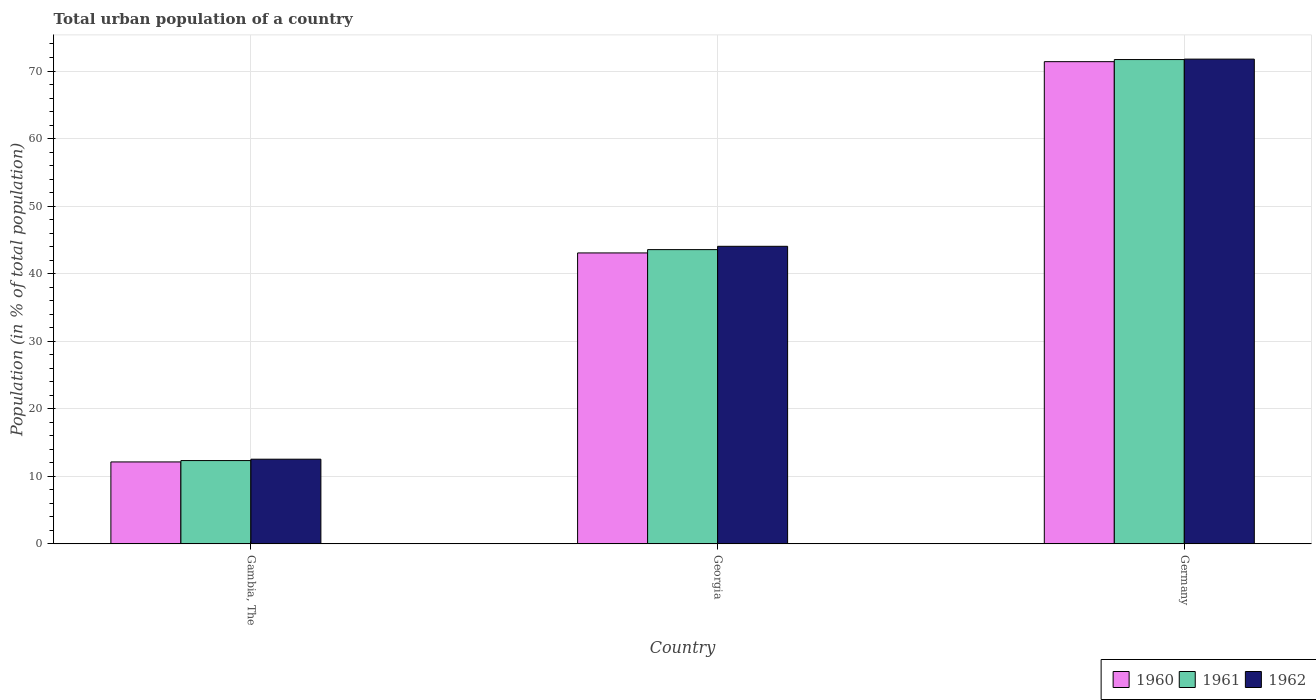How many different coloured bars are there?
Keep it short and to the point. 3. Are the number of bars per tick equal to the number of legend labels?
Your answer should be compact. Yes. Are the number of bars on each tick of the X-axis equal?
Provide a short and direct response. Yes. How many bars are there on the 1st tick from the right?
Provide a short and direct response. 3. What is the label of the 1st group of bars from the left?
Your answer should be very brief. Gambia, The. What is the urban population in 1962 in Georgia?
Provide a succinct answer. 44.05. Across all countries, what is the maximum urban population in 1961?
Your answer should be very brief. 71.7. Across all countries, what is the minimum urban population in 1962?
Your response must be concise. 12.54. In which country was the urban population in 1962 minimum?
Keep it short and to the point. Gambia, The. What is the total urban population in 1960 in the graph?
Provide a short and direct response. 126.58. What is the difference between the urban population in 1961 in Georgia and that in Germany?
Ensure brevity in your answer.  -28.14. What is the difference between the urban population in 1960 in Gambia, The and the urban population in 1962 in Georgia?
Give a very brief answer. -31.92. What is the average urban population in 1960 per country?
Your response must be concise. 42.19. What is the difference between the urban population of/in 1961 and urban population of/in 1962 in Georgia?
Keep it short and to the point. -0.49. What is the ratio of the urban population in 1961 in Georgia to that in Germany?
Make the answer very short. 0.61. Is the urban population in 1961 in Gambia, The less than that in Germany?
Offer a very short reply. Yes. Is the difference between the urban population in 1961 in Georgia and Germany greater than the difference between the urban population in 1962 in Georgia and Germany?
Offer a terse response. No. What is the difference between the highest and the second highest urban population in 1961?
Your answer should be compact. 31.23. What is the difference between the highest and the lowest urban population in 1961?
Keep it short and to the point. 59.37. In how many countries, is the urban population in 1960 greater than the average urban population in 1960 taken over all countries?
Ensure brevity in your answer.  2. Is it the case that in every country, the sum of the urban population in 1961 and urban population in 1960 is greater than the urban population in 1962?
Keep it short and to the point. Yes. How many bars are there?
Your response must be concise. 9. Are all the bars in the graph horizontal?
Ensure brevity in your answer.  No. How many countries are there in the graph?
Keep it short and to the point. 3. Are the values on the major ticks of Y-axis written in scientific E-notation?
Your response must be concise. No. What is the title of the graph?
Provide a short and direct response. Total urban population of a country. What is the label or title of the X-axis?
Offer a very short reply. Country. What is the label or title of the Y-axis?
Give a very brief answer. Population (in % of total population). What is the Population (in % of total population) in 1960 in Gambia, The?
Your answer should be compact. 12.13. What is the Population (in % of total population) in 1961 in Gambia, The?
Your answer should be compact. 12.33. What is the Population (in % of total population) of 1962 in Gambia, The?
Ensure brevity in your answer.  12.54. What is the Population (in % of total population) in 1960 in Georgia?
Offer a very short reply. 43.07. What is the Population (in % of total population) in 1961 in Georgia?
Your response must be concise. 43.56. What is the Population (in % of total population) of 1962 in Georgia?
Your answer should be compact. 44.05. What is the Population (in % of total population) in 1960 in Germany?
Make the answer very short. 71.38. What is the Population (in % of total population) in 1961 in Germany?
Your response must be concise. 71.7. What is the Population (in % of total population) in 1962 in Germany?
Your answer should be very brief. 71.76. Across all countries, what is the maximum Population (in % of total population) of 1960?
Provide a succinct answer. 71.38. Across all countries, what is the maximum Population (in % of total population) of 1961?
Provide a short and direct response. 71.7. Across all countries, what is the maximum Population (in % of total population) of 1962?
Give a very brief answer. 71.76. Across all countries, what is the minimum Population (in % of total population) of 1960?
Your response must be concise. 12.13. Across all countries, what is the minimum Population (in % of total population) of 1961?
Make the answer very short. 12.33. Across all countries, what is the minimum Population (in % of total population) in 1962?
Ensure brevity in your answer.  12.54. What is the total Population (in % of total population) of 1960 in the graph?
Ensure brevity in your answer.  126.58. What is the total Population (in % of total population) of 1961 in the graph?
Provide a succinct answer. 127.59. What is the total Population (in % of total population) in 1962 in the graph?
Your answer should be very brief. 128.35. What is the difference between the Population (in % of total population) in 1960 in Gambia, The and that in Georgia?
Your answer should be very brief. -30.94. What is the difference between the Population (in % of total population) of 1961 in Gambia, The and that in Georgia?
Provide a succinct answer. -31.23. What is the difference between the Population (in % of total population) of 1962 in Gambia, The and that in Georgia?
Offer a terse response. -31.52. What is the difference between the Population (in % of total population) in 1960 in Gambia, The and that in Germany?
Keep it short and to the point. -59.26. What is the difference between the Population (in % of total population) of 1961 in Gambia, The and that in Germany?
Offer a terse response. -59.37. What is the difference between the Population (in % of total population) in 1962 in Gambia, The and that in Germany?
Ensure brevity in your answer.  -59.23. What is the difference between the Population (in % of total population) of 1960 in Georgia and that in Germany?
Provide a short and direct response. -28.32. What is the difference between the Population (in % of total population) in 1961 in Georgia and that in Germany?
Offer a terse response. -28.14. What is the difference between the Population (in % of total population) in 1962 in Georgia and that in Germany?
Your answer should be very brief. -27.71. What is the difference between the Population (in % of total population) in 1960 in Gambia, The and the Population (in % of total population) in 1961 in Georgia?
Offer a terse response. -31.43. What is the difference between the Population (in % of total population) in 1960 in Gambia, The and the Population (in % of total population) in 1962 in Georgia?
Provide a short and direct response. -31.92. What is the difference between the Population (in % of total population) of 1961 in Gambia, The and the Population (in % of total population) of 1962 in Georgia?
Provide a short and direct response. -31.72. What is the difference between the Population (in % of total population) in 1960 in Gambia, The and the Population (in % of total population) in 1961 in Germany?
Your answer should be very brief. -59.57. What is the difference between the Population (in % of total population) of 1960 in Gambia, The and the Population (in % of total population) of 1962 in Germany?
Make the answer very short. -59.63. What is the difference between the Population (in % of total population) in 1961 in Gambia, The and the Population (in % of total population) in 1962 in Germany?
Keep it short and to the point. -59.43. What is the difference between the Population (in % of total population) of 1960 in Georgia and the Population (in % of total population) of 1961 in Germany?
Your answer should be very brief. -28.63. What is the difference between the Population (in % of total population) of 1960 in Georgia and the Population (in % of total population) of 1962 in Germany?
Ensure brevity in your answer.  -28.69. What is the difference between the Population (in % of total population) of 1961 in Georgia and the Population (in % of total population) of 1962 in Germany?
Provide a short and direct response. -28.2. What is the average Population (in % of total population) in 1960 per country?
Your response must be concise. 42.19. What is the average Population (in % of total population) of 1961 per country?
Provide a short and direct response. 42.53. What is the average Population (in % of total population) in 1962 per country?
Keep it short and to the point. 42.78. What is the difference between the Population (in % of total population) in 1960 and Population (in % of total population) in 1961 in Gambia, The?
Offer a terse response. -0.2. What is the difference between the Population (in % of total population) of 1960 and Population (in % of total population) of 1962 in Gambia, The?
Your response must be concise. -0.41. What is the difference between the Population (in % of total population) in 1961 and Population (in % of total population) in 1962 in Gambia, The?
Ensure brevity in your answer.  -0.2. What is the difference between the Population (in % of total population) in 1960 and Population (in % of total population) in 1961 in Georgia?
Provide a short and direct response. -0.49. What is the difference between the Population (in % of total population) of 1960 and Population (in % of total population) of 1962 in Georgia?
Offer a very short reply. -0.98. What is the difference between the Population (in % of total population) of 1961 and Population (in % of total population) of 1962 in Georgia?
Give a very brief answer. -0.49. What is the difference between the Population (in % of total population) of 1960 and Population (in % of total population) of 1961 in Germany?
Provide a succinct answer. -0.31. What is the difference between the Population (in % of total population) of 1960 and Population (in % of total population) of 1962 in Germany?
Your answer should be very brief. -0.38. What is the difference between the Population (in % of total population) of 1961 and Population (in % of total population) of 1962 in Germany?
Make the answer very short. -0.07. What is the ratio of the Population (in % of total population) of 1960 in Gambia, The to that in Georgia?
Give a very brief answer. 0.28. What is the ratio of the Population (in % of total population) in 1961 in Gambia, The to that in Georgia?
Offer a very short reply. 0.28. What is the ratio of the Population (in % of total population) in 1962 in Gambia, The to that in Georgia?
Your answer should be compact. 0.28. What is the ratio of the Population (in % of total population) of 1960 in Gambia, The to that in Germany?
Your answer should be compact. 0.17. What is the ratio of the Population (in % of total population) in 1961 in Gambia, The to that in Germany?
Give a very brief answer. 0.17. What is the ratio of the Population (in % of total population) in 1962 in Gambia, The to that in Germany?
Offer a very short reply. 0.17. What is the ratio of the Population (in % of total population) in 1960 in Georgia to that in Germany?
Offer a very short reply. 0.6. What is the ratio of the Population (in % of total population) of 1961 in Georgia to that in Germany?
Provide a succinct answer. 0.61. What is the ratio of the Population (in % of total population) in 1962 in Georgia to that in Germany?
Your answer should be very brief. 0.61. What is the difference between the highest and the second highest Population (in % of total population) of 1960?
Make the answer very short. 28.32. What is the difference between the highest and the second highest Population (in % of total population) of 1961?
Ensure brevity in your answer.  28.14. What is the difference between the highest and the second highest Population (in % of total population) in 1962?
Provide a short and direct response. 27.71. What is the difference between the highest and the lowest Population (in % of total population) in 1960?
Keep it short and to the point. 59.26. What is the difference between the highest and the lowest Population (in % of total population) in 1961?
Ensure brevity in your answer.  59.37. What is the difference between the highest and the lowest Population (in % of total population) in 1962?
Your answer should be compact. 59.23. 